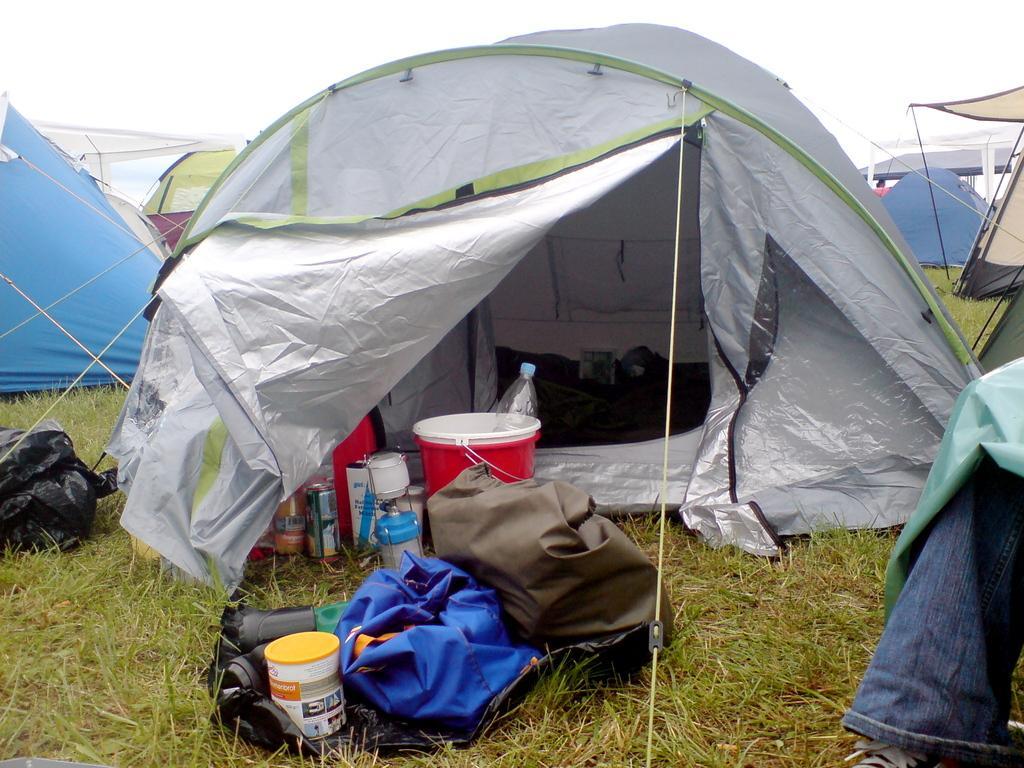How would you summarize this image in a sentence or two? In this image, there are a few tents. We can see the ground with some objects like a bottle, a tin, buckets. We can also see a black colored object on the left. We can see some cloth on the right. We can see the sky. 